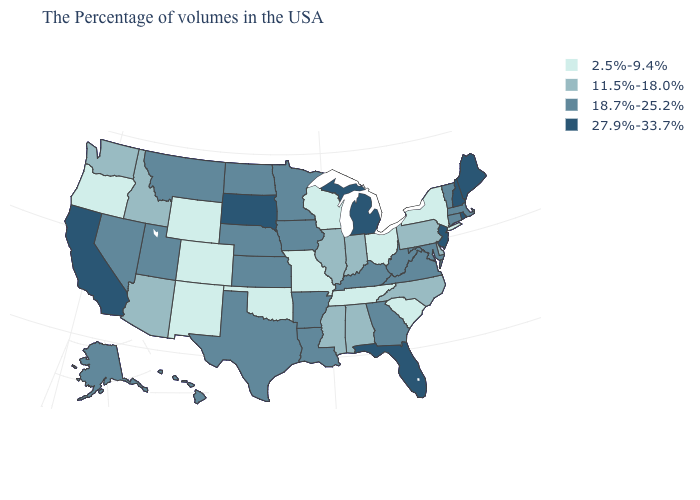Does Michigan have the highest value in the MidWest?
Be succinct. Yes. Which states have the lowest value in the Northeast?
Concise answer only. New York. Name the states that have a value in the range 11.5%-18.0%?
Give a very brief answer. Delaware, Pennsylvania, North Carolina, Indiana, Alabama, Illinois, Mississippi, Arizona, Idaho, Washington. Which states have the lowest value in the USA?
Give a very brief answer. New York, South Carolina, Ohio, Tennessee, Wisconsin, Missouri, Oklahoma, Wyoming, Colorado, New Mexico, Oregon. What is the value of Hawaii?
Be succinct. 18.7%-25.2%. Does Iowa have the lowest value in the USA?
Write a very short answer. No. How many symbols are there in the legend?
Concise answer only. 4. How many symbols are there in the legend?
Give a very brief answer. 4. Does the first symbol in the legend represent the smallest category?
Be succinct. Yes. Which states have the highest value in the USA?
Write a very short answer. Maine, Rhode Island, New Hampshire, New Jersey, Florida, Michigan, South Dakota, California. Which states have the lowest value in the South?
Quick response, please. South Carolina, Tennessee, Oklahoma. Does Alabama have the highest value in the South?
Be succinct. No. What is the value of New York?
Quick response, please. 2.5%-9.4%. Among the states that border Colorado , which have the highest value?
Keep it brief. Kansas, Nebraska, Utah. What is the highest value in states that border Nebraska?
Answer briefly. 27.9%-33.7%. 